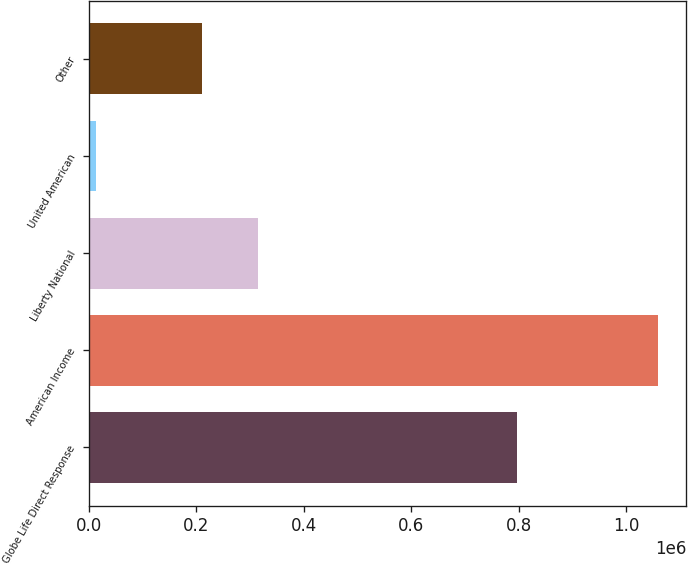<chart> <loc_0><loc_0><loc_500><loc_500><bar_chart><fcel>Globe Life Direct Response<fcel>American Income<fcel>Liberty National<fcel>United American<fcel>Other<nl><fcel>796628<fcel>1.05922e+06<fcel>314608<fcel>12121<fcel>209899<nl></chart> 